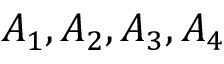Convert formula to latex. <formula><loc_0><loc_0><loc_500><loc_500>A _ { 1 } , A _ { 2 } , A _ { 3 } , A _ { 4 }</formula> 